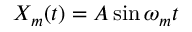Convert formula to latex. <formula><loc_0><loc_0><loc_500><loc_500>X _ { m } ( t ) = A \sin \omega _ { m } t</formula> 